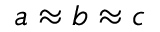<formula> <loc_0><loc_0><loc_500><loc_500>{ a \approx b \approx c }</formula> 